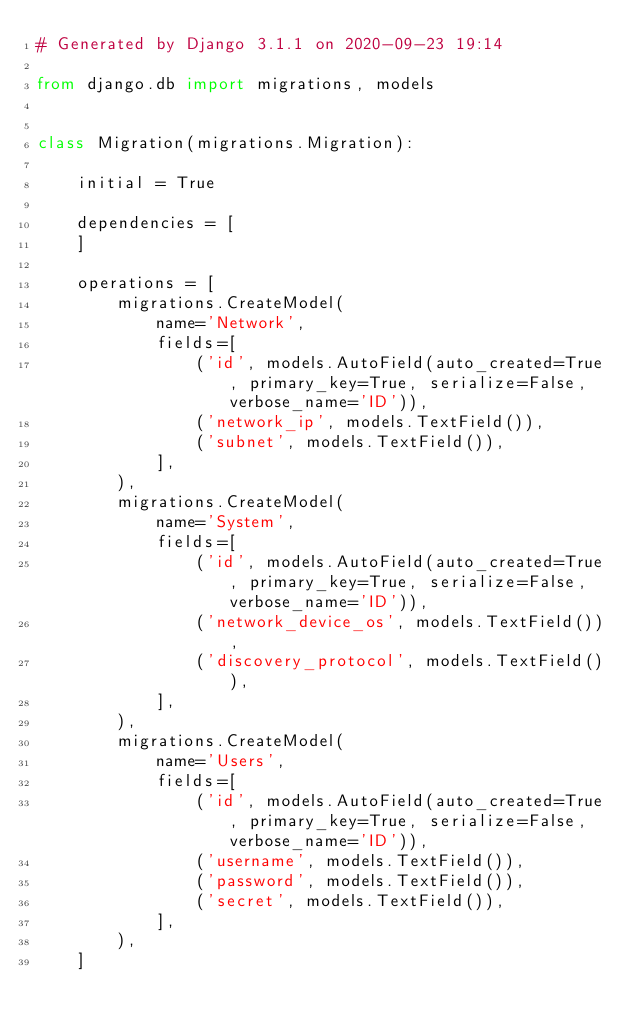Convert code to text. <code><loc_0><loc_0><loc_500><loc_500><_Python_># Generated by Django 3.1.1 on 2020-09-23 19:14

from django.db import migrations, models


class Migration(migrations.Migration):

    initial = True

    dependencies = [
    ]

    operations = [
        migrations.CreateModel(
            name='Network',
            fields=[
                ('id', models.AutoField(auto_created=True, primary_key=True, serialize=False, verbose_name='ID')),
                ('network_ip', models.TextField()),
                ('subnet', models.TextField()),
            ],
        ),
        migrations.CreateModel(
            name='System',
            fields=[
                ('id', models.AutoField(auto_created=True, primary_key=True, serialize=False, verbose_name='ID')),
                ('network_device_os', models.TextField()),
                ('discovery_protocol', models.TextField()),
            ],
        ),
        migrations.CreateModel(
            name='Users',
            fields=[
                ('id', models.AutoField(auto_created=True, primary_key=True, serialize=False, verbose_name='ID')),
                ('username', models.TextField()),
                ('password', models.TextField()),
                ('secret', models.TextField()),
            ],
        ),
    ]
</code> 